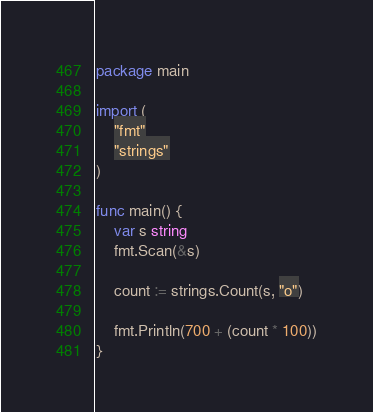<code> <loc_0><loc_0><loc_500><loc_500><_Go_>package main

import (
	"fmt"
	"strings"
)

func main() {
	var s string
	fmt.Scan(&s)

	count := strings.Count(s, "o")

	fmt.Println(700 + (count * 100))
}
</code> 